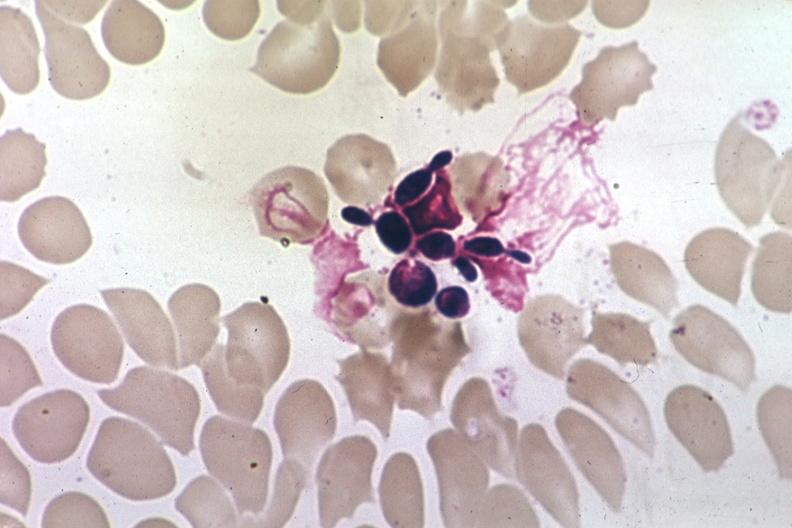what is present?
Answer the question using a single word or phrase. Blood 